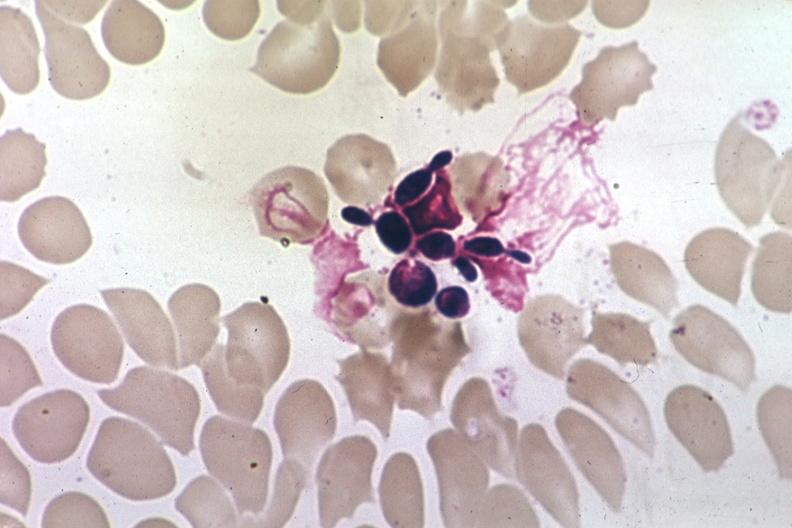what is present?
Answer the question using a single word or phrase. Blood 